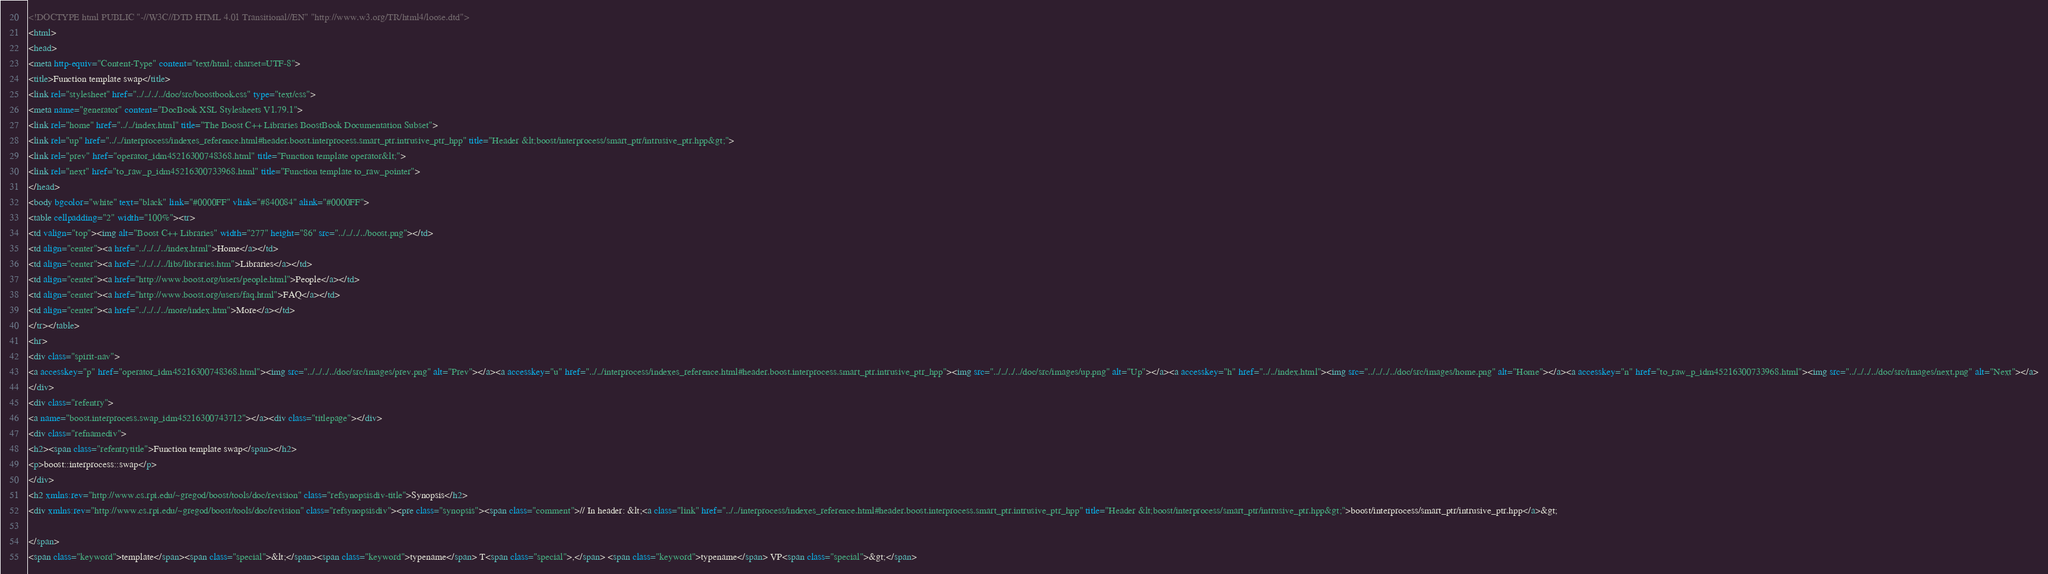<code> <loc_0><loc_0><loc_500><loc_500><_HTML_><!DOCTYPE html PUBLIC "-//W3C//DTD HTML 4.01 Transitional//EN" "http://www.w3.org/TR/html4/loose.dtd">
<html>
<head>
<meta http-equiv="Content-Type" content="text/html; charset=UTF-8">
<title>Function template swap</title>
<link rel="stylesheet" href="../../../../doc/src/boostbook.css" type="text/css">
<meta name="generator" content="DocBook XSL Stylesheets V1.79.1">
<link rel="home" href="../../index.html" title="The Boost C++ Libraries BoostBook Documentation Subset">
<link rel="up" href="../../interprocess/indexes_reference.html#header.boost.interprocess.smart_ptr.intrusive_ptr_hpp" title="Header &lt;boost/interprocess/smart_ptr/intrusive_ptr.hpp&gt;">
<link rel="prev" href="operator_idm45216300748368.html" title="Function template operator&lt;">
<link rel="next" href="to_raw_p_idm45216300733968.html" title="Function template to_raw_pointer">
</head>
<body bgcolor="white" text="black" link="#0000FF" vlink="#840084" alink="#0000FF">
<table cellpadding="2" width="100%"><tr>
<td valign="top"><img alt="Boost C++ Libraries" width="277" height="86" src="../../../../boost.png"></td>
<td align="center"><a href="../../../../index.html">Home</a></td>
<td align="center"><a href="../../../../libs/libraries.htm">Libraries</a></td>
<td align="center"><a href="http://www.boost.org/users/people.html">People</a></td>
<td align="center"><a href="http://www.boost.org/users/faq.html">FAQ</a></td>
<td align="center"><a href="../../../../more/index.htm">More</a></td>
</tr></table>
<hr>
<div class="spirit-nav">
<a accesskey="p" href="operator_idm45216300748368.html"><img src="../../../../doc/src/images/prev.png" alt="Prev"></a><a accesskey="u" href="../../interprocess/indexes_reference.html#header.boost.interprocess.smart_ptr.intrusive_ptr_hpp"><img src="../../../../doc/src/images/up.png" alt="Up"></a><a accesskey="h" href="../../index.html"><img src="../../../../doc/src/images/home.png" alt="Home"></a><a accesskey="n" href="to_raw_p_idm45216300733968.html"><img src="../../../../doc/src/images/next.png" alt="Next"></a>
</div>
<div class="refentry">
<a name="boost.interprocess.swap_idm45216300743712"></a><div class="titlepage"></div>
<div class="refnamediv">
<h2><span class="refentrytitle">Function template swap</span></h2>
<p>boost::interprocess::swap</p>
</div>
<h2 xmlns:rev="http://www.cs.rpi.edu/~gregod/boost/tools/doc/revision" class="refsynopsisdiv-title">Synopsis</h2>
<div xmlns:rev="http://www.cs.rpi.edu/~gregod/boost/tools/doc/revision" class="refsynopsisdiv"><pre class="synopsis"><span class="comment">// In header: &lt;<a class="link" href="../../interprocess/indexes_reference.html#header.boost.interprocess.smart_ptr.intrusive_ptr_hpp" title="Header &lt;boost/interprocess/smart_ptr/intrusive_ptr.hpp&gt;">boost/interprocess/smart_ptr/intrusive_ptr.hpp</a>&gt;

</span>
<span class="keyword">template</span><span class="special">&lt;</span><span class="keyword">typename</span> T<span class="special">,</span> <span class="keyword">typename</span> VP<span class="special">&gt;</span> </code> 